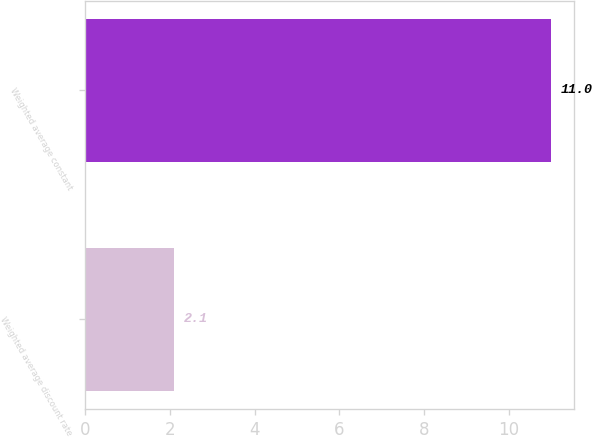Convert chart. <chart><loc_0><loc_0><loc_500><loc_500><bar_chart><fcel>Weighted average discount rate<fcel>Weighted average constant<nl><fcel>2.1<fcel>11<nl></chart> 